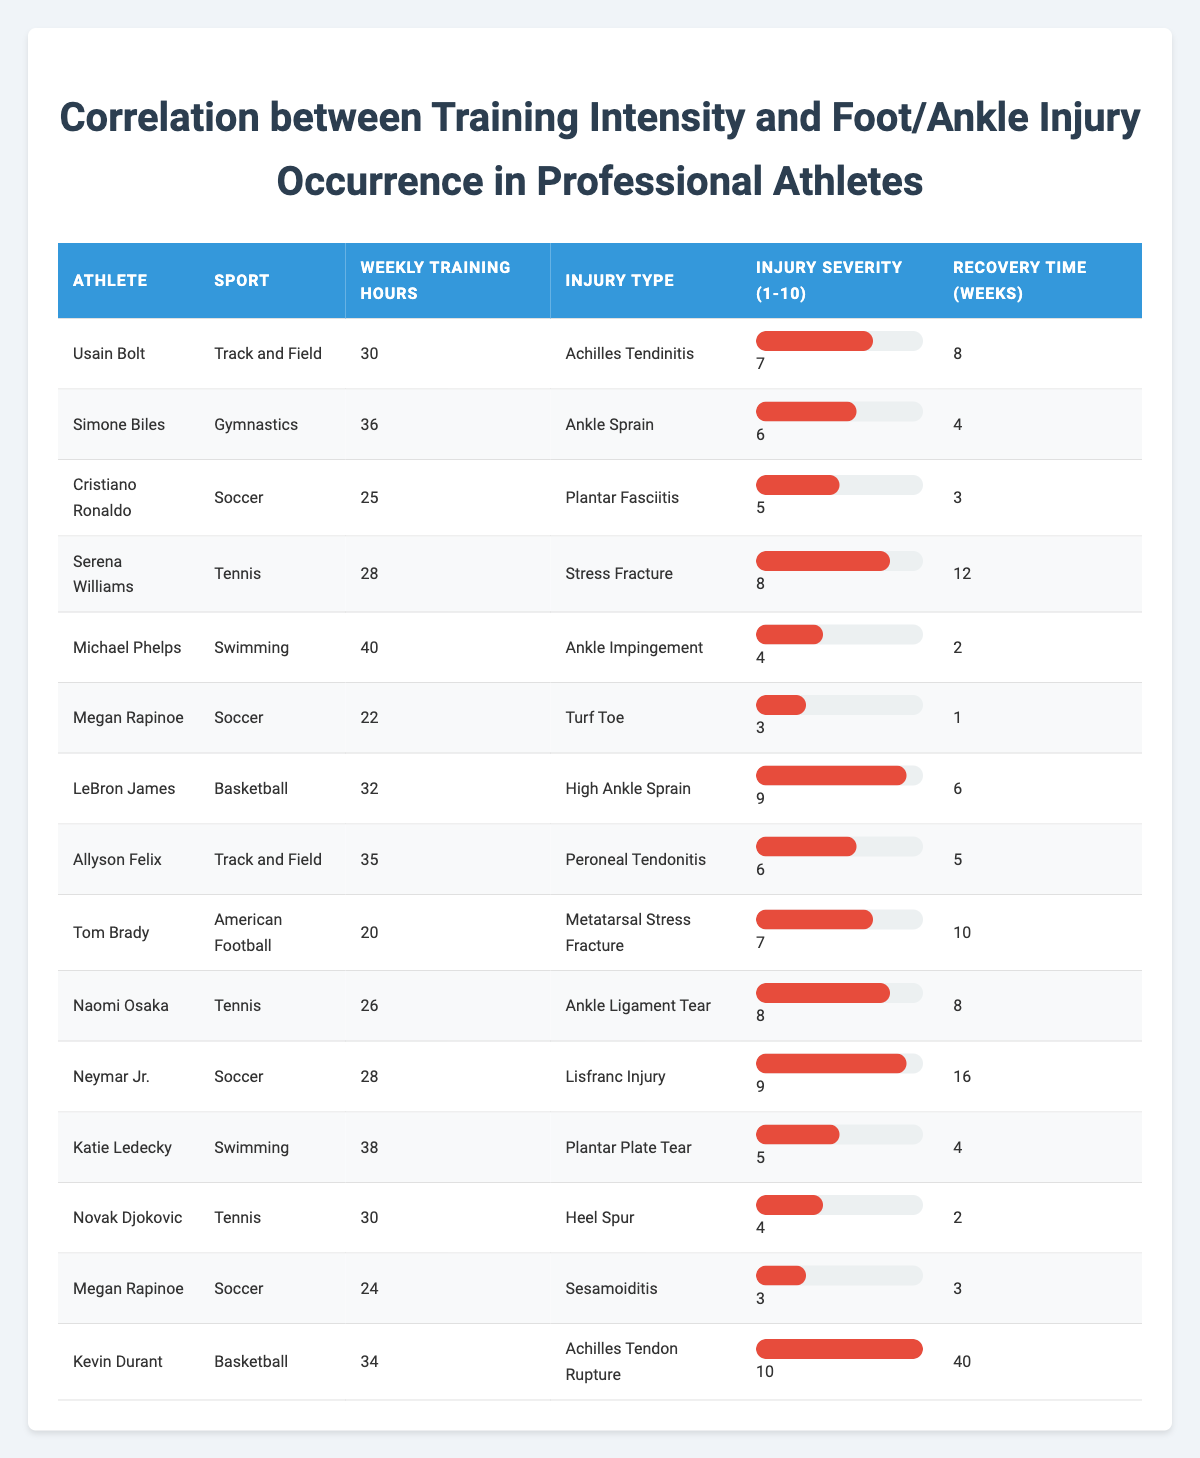What is the injury type of Usain Bolt? Referring to the table, Usain Bolt's row shows "Achilles Tendinitis" as the injury type.
Answer: Achilles Tendinitis How many weekly training hours does Cristiano Ronaldo have? The data for Cristiano Ronaldo indicates he has 25 weekly training hours.
Answer: 25 What is the injury severity of Kevin Durant? According to Kevin Durant's entry, the injury severity is rated as 10 on a scale of 1 to 10.
Answer: 10 Which athlete has the longest recovery time? By comparing the recovery time for all athletes, Kevin Durant has the longest recovery time of 40 weeks.
Answer: 40 weeks Is it true that Michael Phelps has a lower injury severity than Serena Williams? Michael Phelps has an injury severity of 4, while Serena Williams has an injury severity of 8; therefore, the statement is true.
Answer: True What is the average weekly training hours of athletes who suffered from 'Ankle Sprain'? There are two athletes with 'Ankle Sprain': Simone Biles (36 hours) and LeBron James (32 hours). The average is (36 + 32) / 2 = 34 hours.
Answer: 34 How many athletes trained more than 30 hours per week and suffered from an injury severity rating of 8 or higher? The athletes fitting this criteria are Serena Williams (8), LeBron James (9), Neymar Jr. (9), and Kevin Durant (10). Thus, there are 4 athletes.
Answer: 4 What is the total recovery time for athletes with an injury severity of 6 or higher? The relevant athletes are Usain Bolt (8 weeks), LeBron James (6 weeks), Serena Williams (12 weeks), Neymar Jr. (16 weeks), and Kevin Durant (40 weeks). Total recovery time = 8 + 6 + 12 + 16 + 40 = 82 weeks.
Answer: 82 weeks How does the training intensity of athletes with ‘Lisfranc Injury’ compare to those with ‘Stress Fracture’? Neymar Jr., with a ‘Lisfranc Injury’, has 28 weekly training hours, while Serena Williams, with a ‘Stress Fracture’, has 28 weekly training hours as well. Thus, they are equal.
Answer: Equal Which sport had the highest average injury severity among the listed athletes? Evaluating the injury severities: Track and Field (7, 6), Gymnastics (6), Soccer (5, 3, 9, 8), Tennis (8, 4), Swimming (4, 5), Basketball (9, 10), American Football (7). The average injury severity for Basketball = (9 + 10) / 2 = 9.5, which is the highest.
Answer: Basketball 